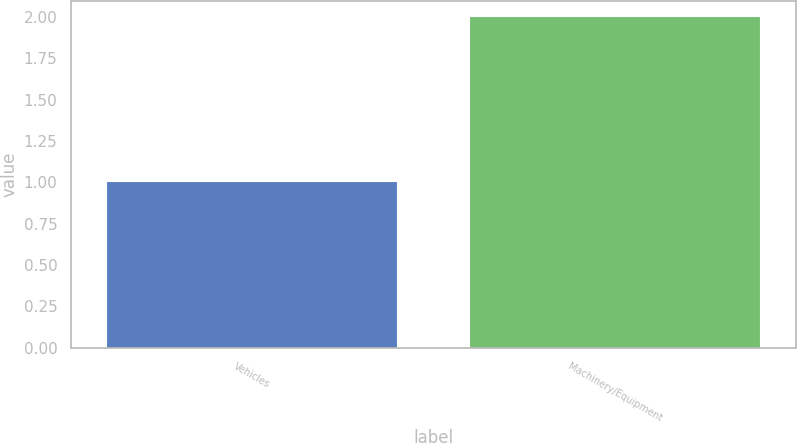Convert chart. <chart><loc_0><loc_0><loc_500><loc_500><bar_chart><fcel>Vehicles<fcel>Machinery/Equipment<nl><fcel>1<fcel>2<nl></chart> 